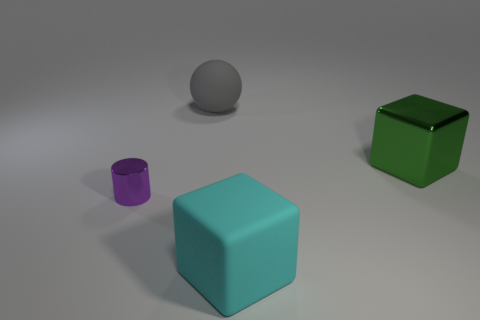There is a gray rubber sphere that is behind the green metallic object; does it have the same size as the cylinder?
Your response must be concise. No. There is another shiny thing that is the same size as the cyan object; what color is it?
Offer a very short reply. Green. Are there any large green metallic things that are to the left of the cube behind the big block that is in front of the green block?
Your answer should be compact. No. What is the object left of the large matte ball made of?
Your response must be concise. Metal. Do the small purple metal object and the shiny thing that is on the right side of the purple cylinder have the same shape?
Offer a very short reply. No. Is the number of purple metallic objects behind the purple thing the same as the number of small metallic things that are to the left of the big green metal object?
Ensure brevity in your answer.  No. What number of rubber things are small cylinders or big gray cubes?
Give a very brief answer. 0. Does the large rubber object behind the small purple metallic object have the same shape as the purple shiny thing?
Offer a very short reply. No. Are there more large metal blocks on the left side of the purple metallic thing than green blocks?
Keep it short and to the point. No. How many large things are both to the right of the matte sphere and behind the tiny cylinder?
Your answer should be compact. 1. 